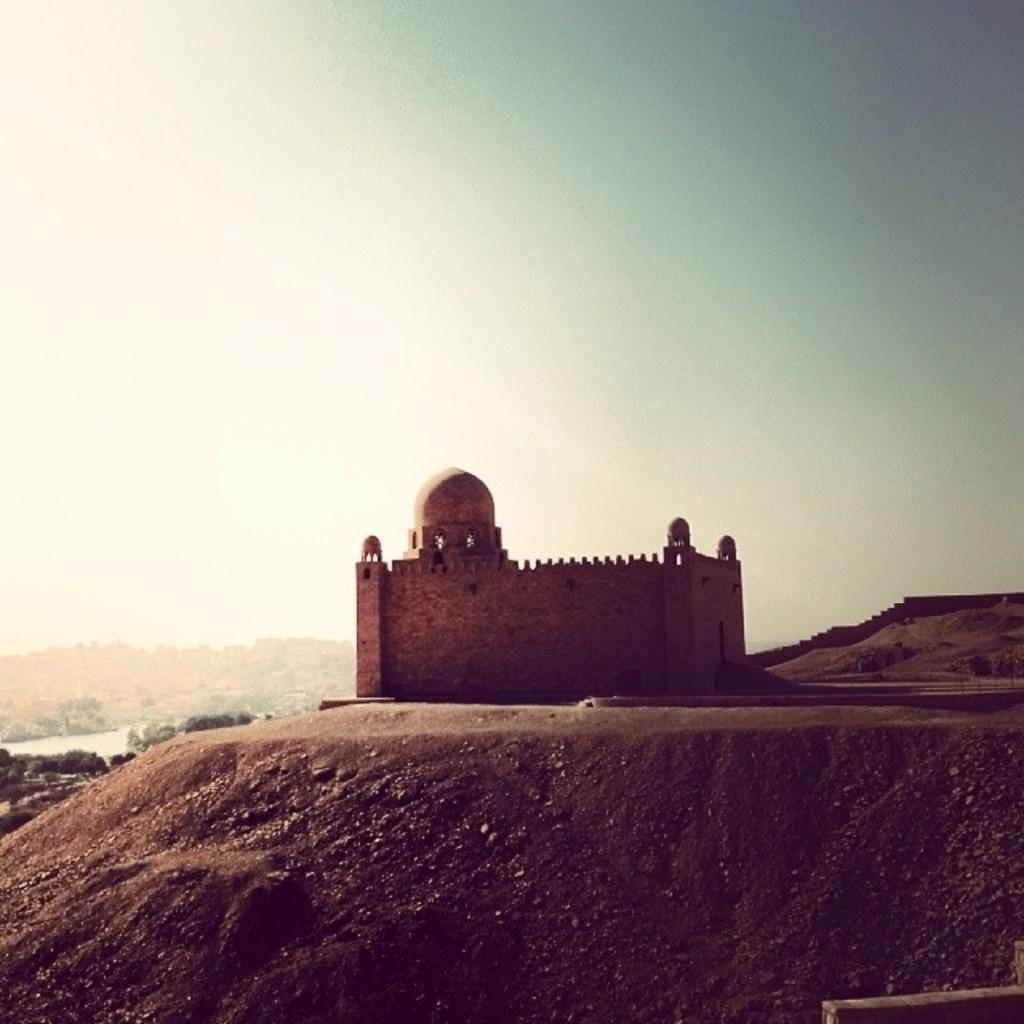What is the main subject of the image? There is a monument in the image. Where is the monument located? The monument is on a mountain. What can be seen in the background of the image? There are other mountains, a wall, and trees visible in the background. What is on the left side of the image? There is water on the left side of the image. What is visible at the top of the image? The sky is visible at the top of the image. How many pizzas are being delivered to the monument in the image? There are no pizzas or delivery in the image; it features a monument on a mountain with other background elements. Can you read the letter that is on the monument in the image? There is no letter or text visible on the monument in the image. 